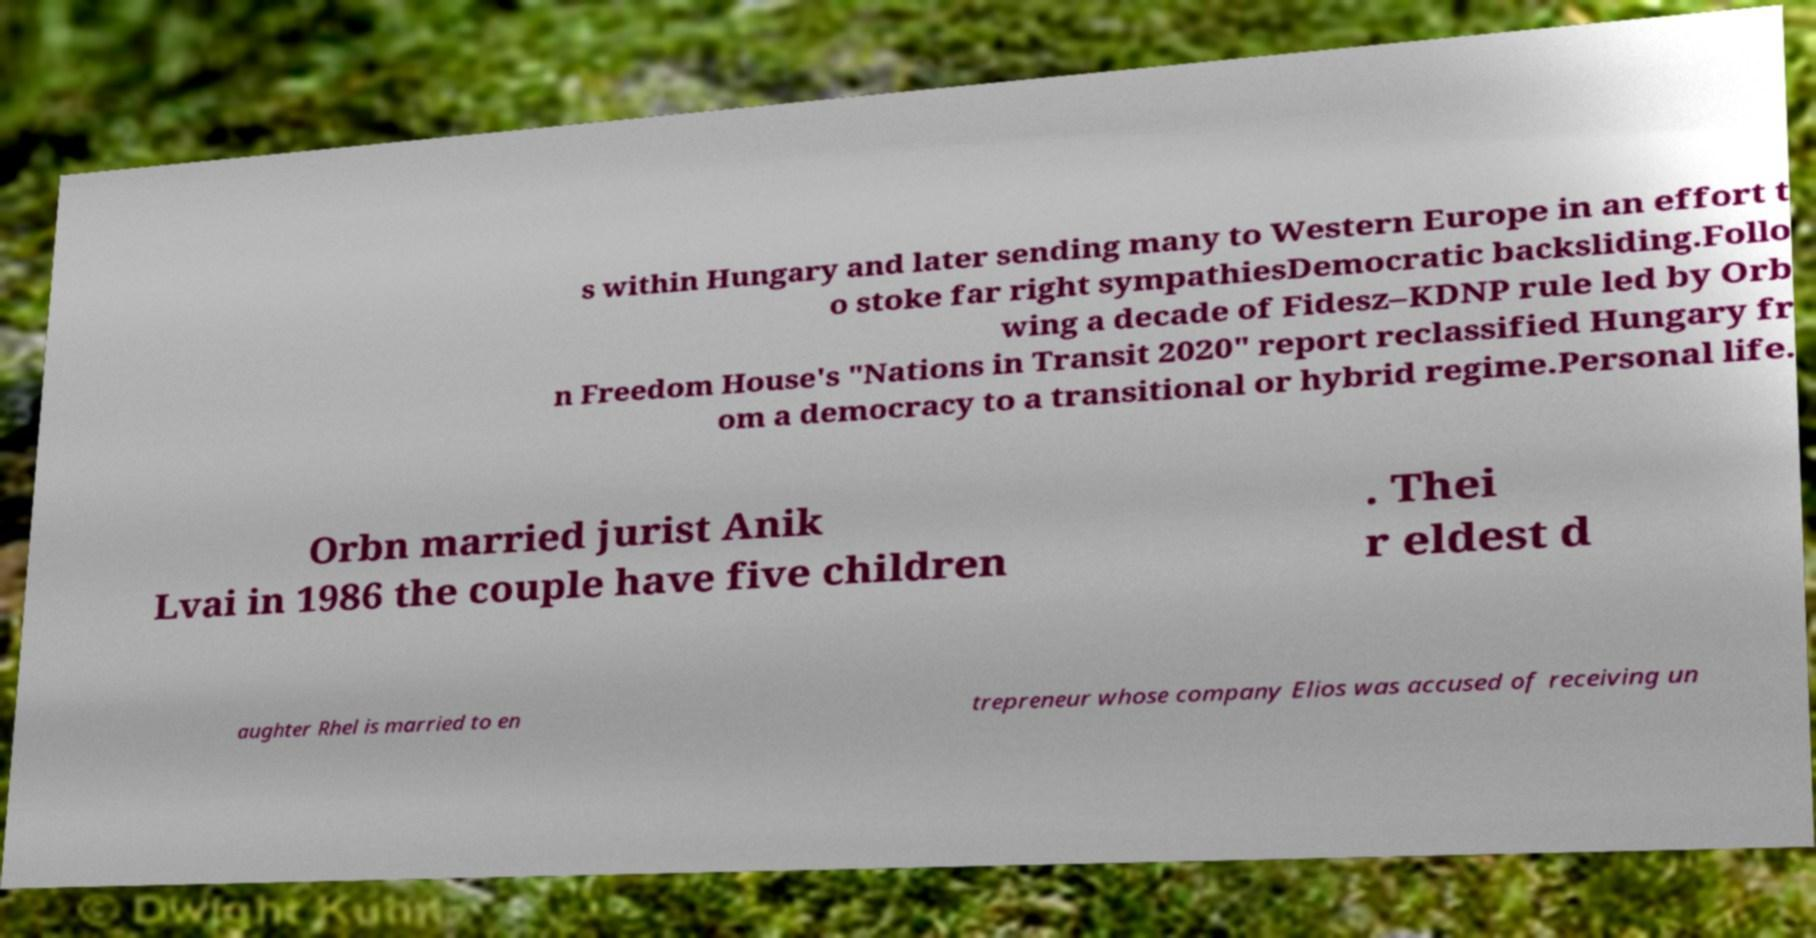Could you assist in decoding the text presented in this image and type it out clearly? s within Hungary and later sending many to Western Europe in an effort t o stoke far right sympathiesDemocratic backsliding.Follo wing a decade of Fidesz–KDNP rule led by Orb n Freedom House's "Nations in Transit 2020" report reclassified Hungary fr om a democracy to a transitional or hybrid regime.Personal life. Orbn married jurist Anik Lvai in 1986 the couple have five children . Thei r eldest d aughter Rhel is married to en trepreneur whose company Elios was accused of receiving un 